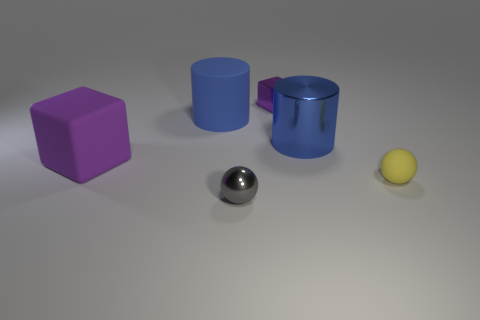There is a ball that is on the left side of the large metal cylinder; is it the same size as the blue object right of the rubber cylinder?
Offer a terse response. No. Is there another ball of the same size as the gray metallic ball?
Provide a short and direct response. Yes. There is a blue object that is left of the purple metal object; is it the same shape as the tiny yellow rubber thing?
Give a very brief answer. No. What is the material of the purple object behind the metallic cylinder?
Ensure brevity in your answer.  Metal. There is a tiny thing that is in front of the tiny ball that is on the right side of the gray thing; what shape is it?
Keep it short and to the point. Sphere. Do the small gray metallic object and the large thing that is to the right of the tiny metal cube have the same shape?
Your answer should be compact. No. There is a large rubber object to the right of the purple matte thing; how many big blue things are right of it?
Offer a very short reply. 1. What material is the big purple object that is the same shape as the small purple metallic object?
Your answer should be compact. Rubber. What number of blue things are either small balls or cubes?
Your response must be concise. 0. Are there any other things that have the same color as the small metallic sphere?
Provide a succinct answer. No. 